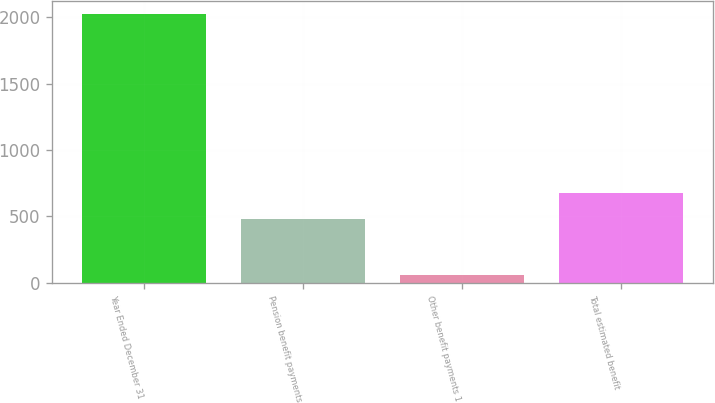Convert chart. <chart><loc_0><loc_0><loc_500><loc_500><bar_chart><fcel>Year Ended December 31<fcel>Pension benefit payments<fcel>Other benefit payments 1<fcel>Total estimated benefit<nl><fcel>2023<fcel>480<fcel>55<fcel>676.8<nl></chart> 